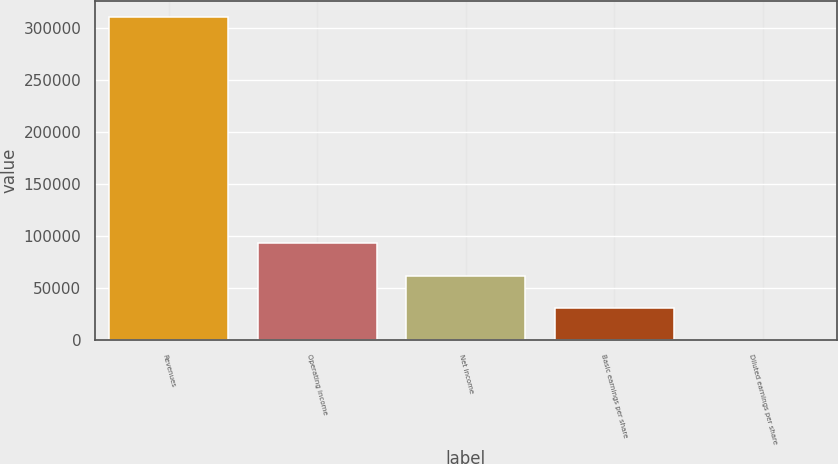Convert chart. <chart><loc_0><loc_0><loc_500><loc_500><bar_chart><fcel>Revenues<fcel>Operating income<fcel>Net income<fcel>Basic earnings per share<fcel>Diluted earnings per share<nl><fcel>310980<fcel>93294.4<fcel>62196.4<fcel>31098.5<fcel>0.53<nl></chart> 